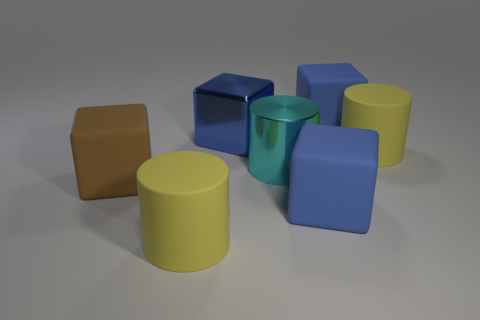How many blue blocks must be subtracted to get 1 blue blocks? 2 Subtract all red balls. How many blue blocks are left? 3 Add 2 small blue blocks. How many objects exist? 9 Subtract all cylinders. How many objects are left? 4 Add 7 large blue cubes. How many large blue cubes exist? 10 Subtract 0 green blocks. How many objects are left? 7 Subtract all big cyan shiny things. Subtract all large green metal spheres. How many objects are left? 6 Add 1 matte objects. How many matte objects are left? 6 